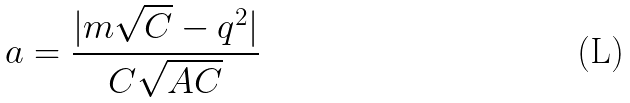<formula> <loc_0><loc_0><loc_500><loc_500>a = \frac { | m { \sqrt { C } } - q ^ { 2 } | } { C \sqrt { A C } }</formula> 